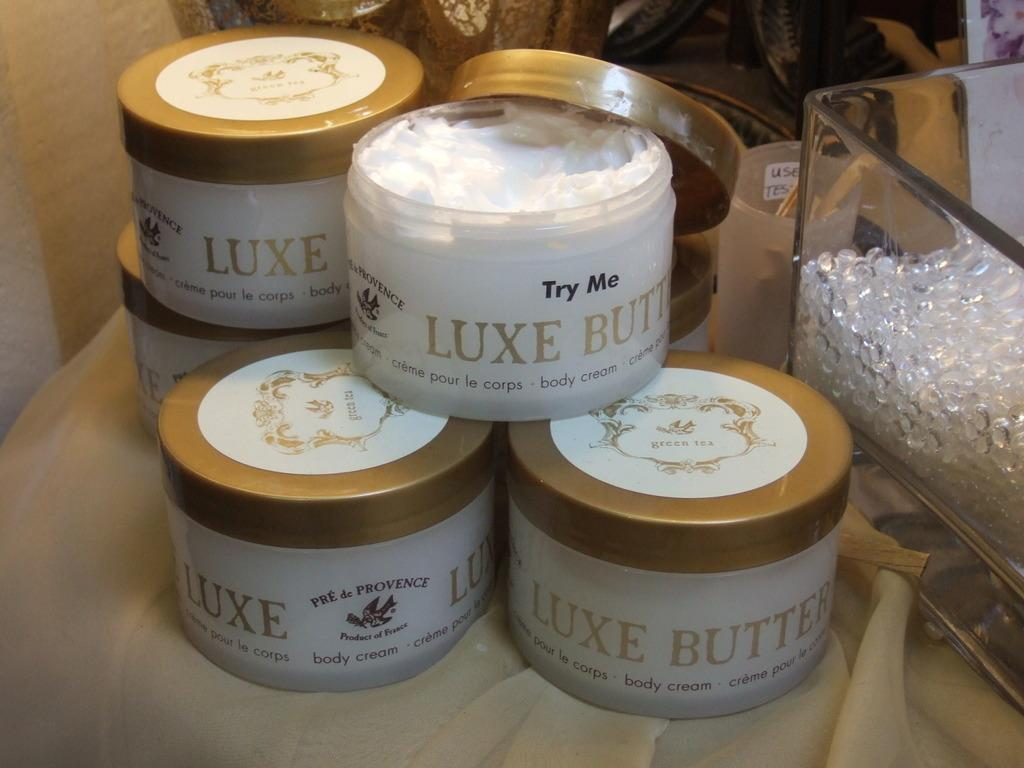<image>
Present a compact description of the photo's key features. a few jars of Luxe Butte sitting with each other 